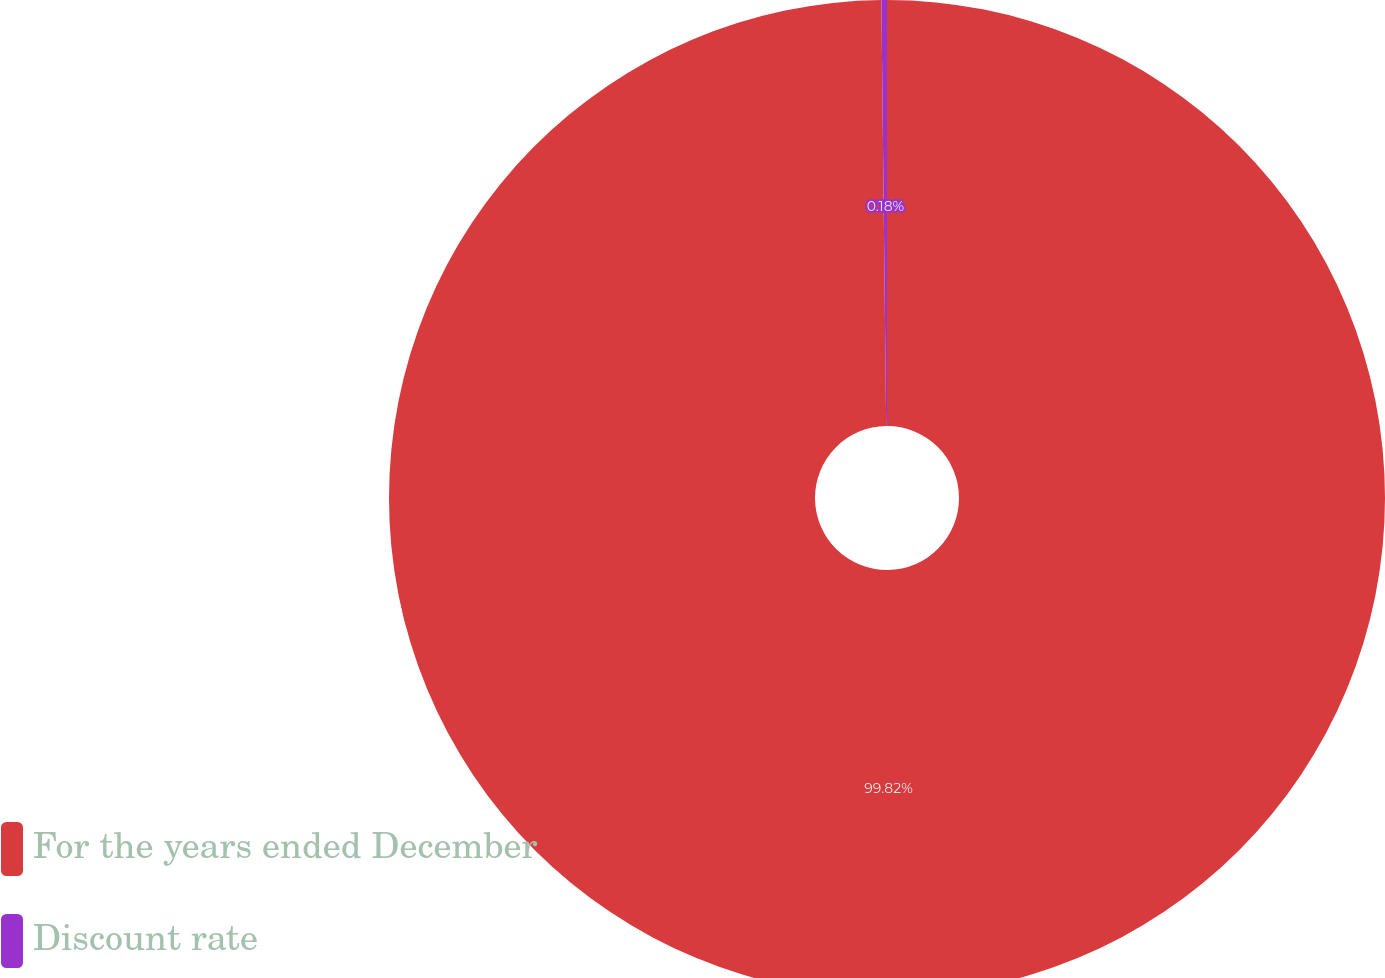<chart> <loc_0><loc_0><loc_500><loc_500><pie_chart><fcel>For the years ended December<fcel>Discount rate<nl><fcel>99.82%<fcel>0.18%<nl></chart> 